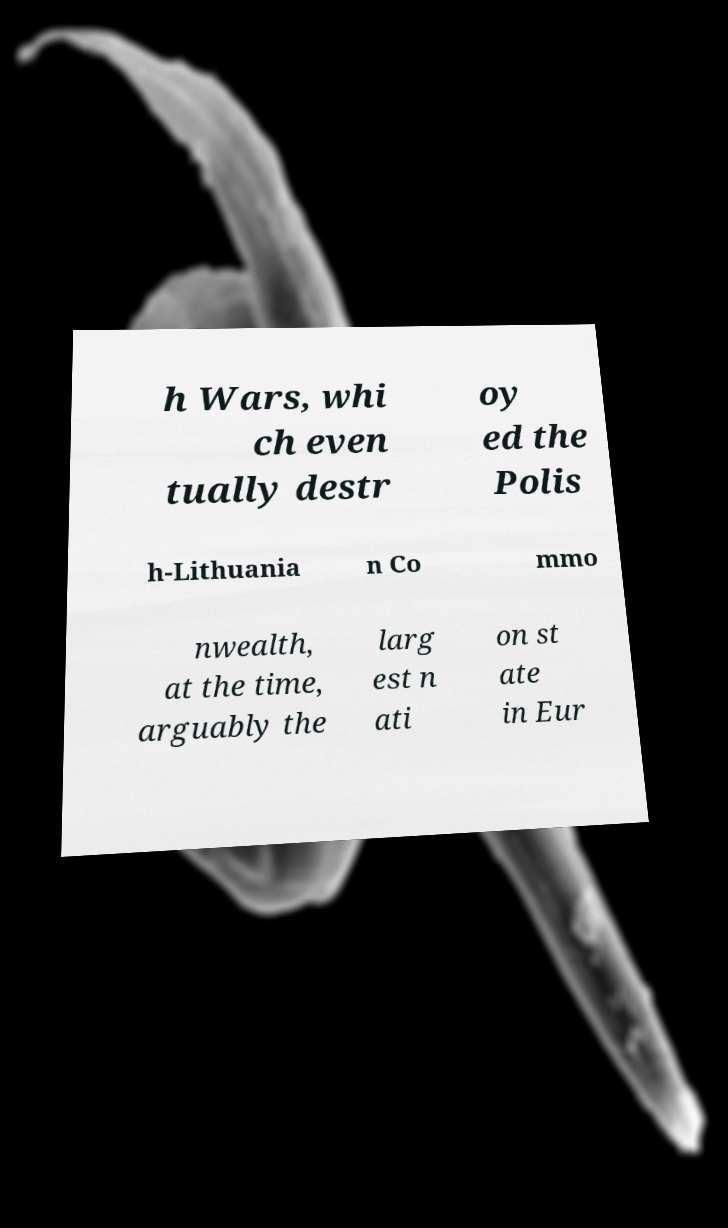For documentation purposes, I need the text within this image transcribed. Could you provide that? h Wars, whi ch even tually destr oy ed the Polis h-Lithuania n Co mmo nwealth, at the time, arguably the larg est n ati on st ate in Eur 